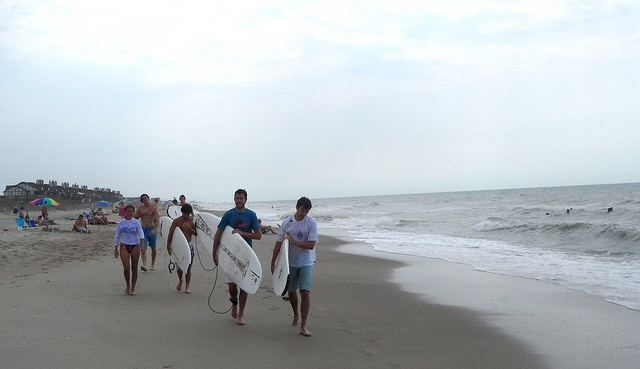Describe the objects in this image and their specific colors. I can see people in white, gray, black, and maroon tones, surfboard in white, darkgray, and gray tones, people in white, black, navy, gray, and maroon tones, people in white, gray, darkgray, and black tones, and people in white, black, gray, and maroon tones in this image. 